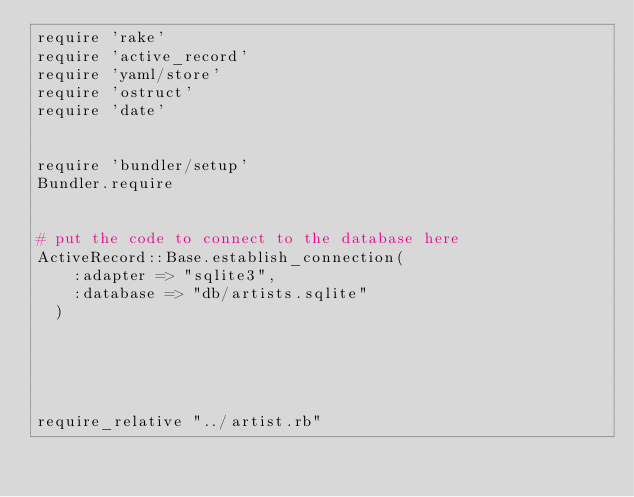Convert code to text. <code><loc_0><loc_0><loc_500><loc_500><_Ruby_>require 'rake'
require 'active_record'
require 'yaml/store'
require 'ostruct'
require 'date'


require 'bundler/setup'
Bundler.require


# put the code to connect to the database here
ActiveRecord::Base.establish_connection(
    :adapter => "sqlite3",
    :database => "db/artists.sqlite"
  )





require_relative "../artist.rb"
</code> 